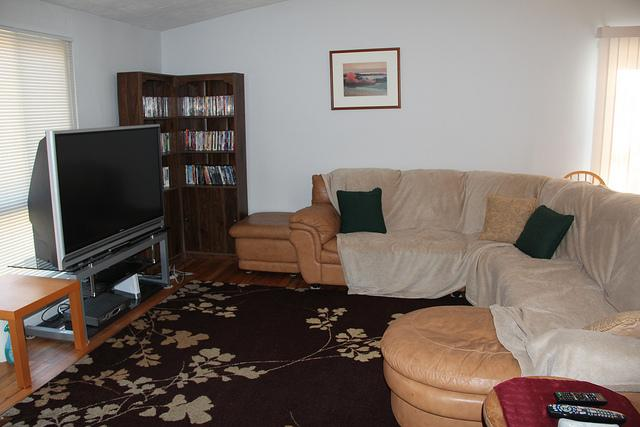How many portraits are hung on the white wall?

Choices:
A) three
B) two
C) four
D) one one 